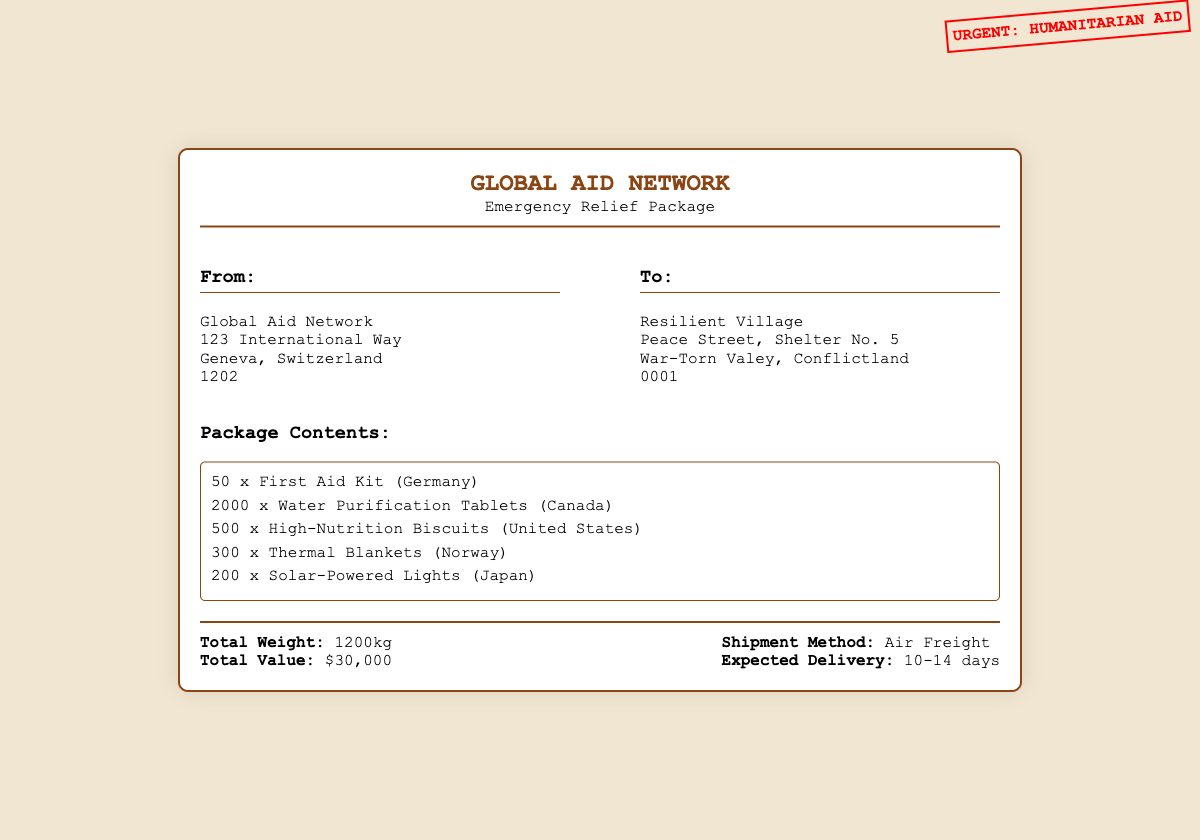what is the name of the organization sending the package? The name of the organization is mentioned at the header of the document.
Answer: GLOBAL AID NETWORK what is the total weight of the shipment? The total weight of the shipment is specified in the footer section of the document.
Answer: 1200kg how many First Aid Kits are included in the package? The quantity of First Aid Kits can be found in the package contents.
Answer: 50 what is the expected delivery time for the shipment? The expected delivery time is noted in the footer of the document.
Answer: 10-14 days how many Water Purification Tablets are included? The amount of Water Purification Tablets is part of the itemized list in the document.
Answer: 2000 from which country are the Thermal Blankets sourced? The country of origin for the Thermal Blankets is mentioned next to the item in the package contents.
Answer: Norway what is the total value of the package? The total value of the shipment is provided in the footer section of the document.
Answer: $30,000 what shipment method is being used? The method of shipment is listed in the footer.
Answer: Air Freight how many Solar-Powered Lights are included? The number of Solar-Powered Lights is described in the package contents section.
Answer: 200 